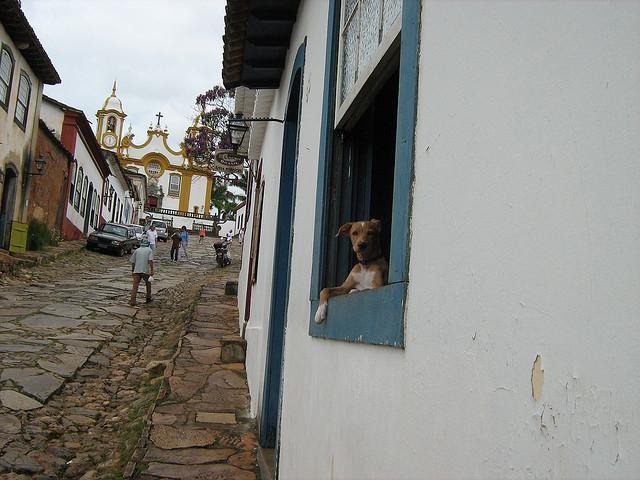How many motorcycles are there?
Give a very brief answer. 0. 